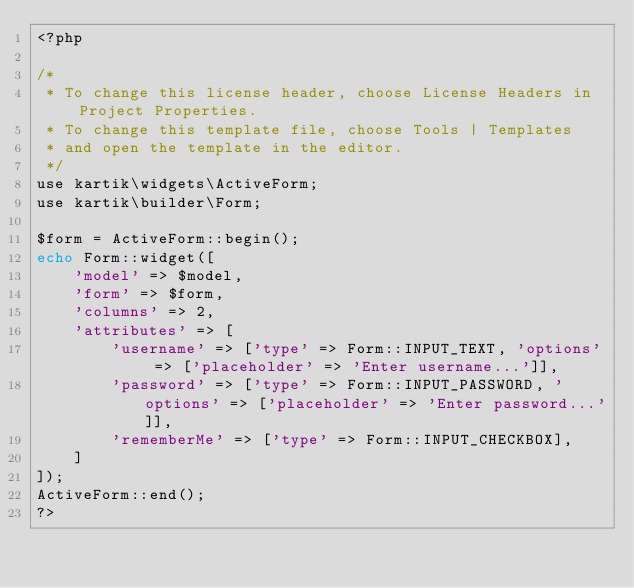Convert code to text. <code><loc_0><loc_0><loc_500><loc_500><_PHP_><?php

/* 
 * To change this license header, choose License Headers in Project Properties.
 * To change this template file, choose Tools | Templates
 * and open the template in the editor.
 */
use kartik\widgets\ActiveForm;
use kartik\builder\Form;

$form = ActiveForm::begin();
echo Form::widget([
    'model' => $model,
    'form' => $form,
    'columns' => 2,
    'attributes' => [
        'username' => ['type' => Form::INPUT_TEXT, 'options' => ['placeholder' => 'Enter username...']],
        'password' => ['type' => Form::INPUT_PASSWORD, 'options' => ['placeholder' => 'Enter password...']],
        'rememberMe' => ['type' => Form::INPUT_CHECKBOX],
    ]
]);
ActiveForm::end();
?>

</code> 